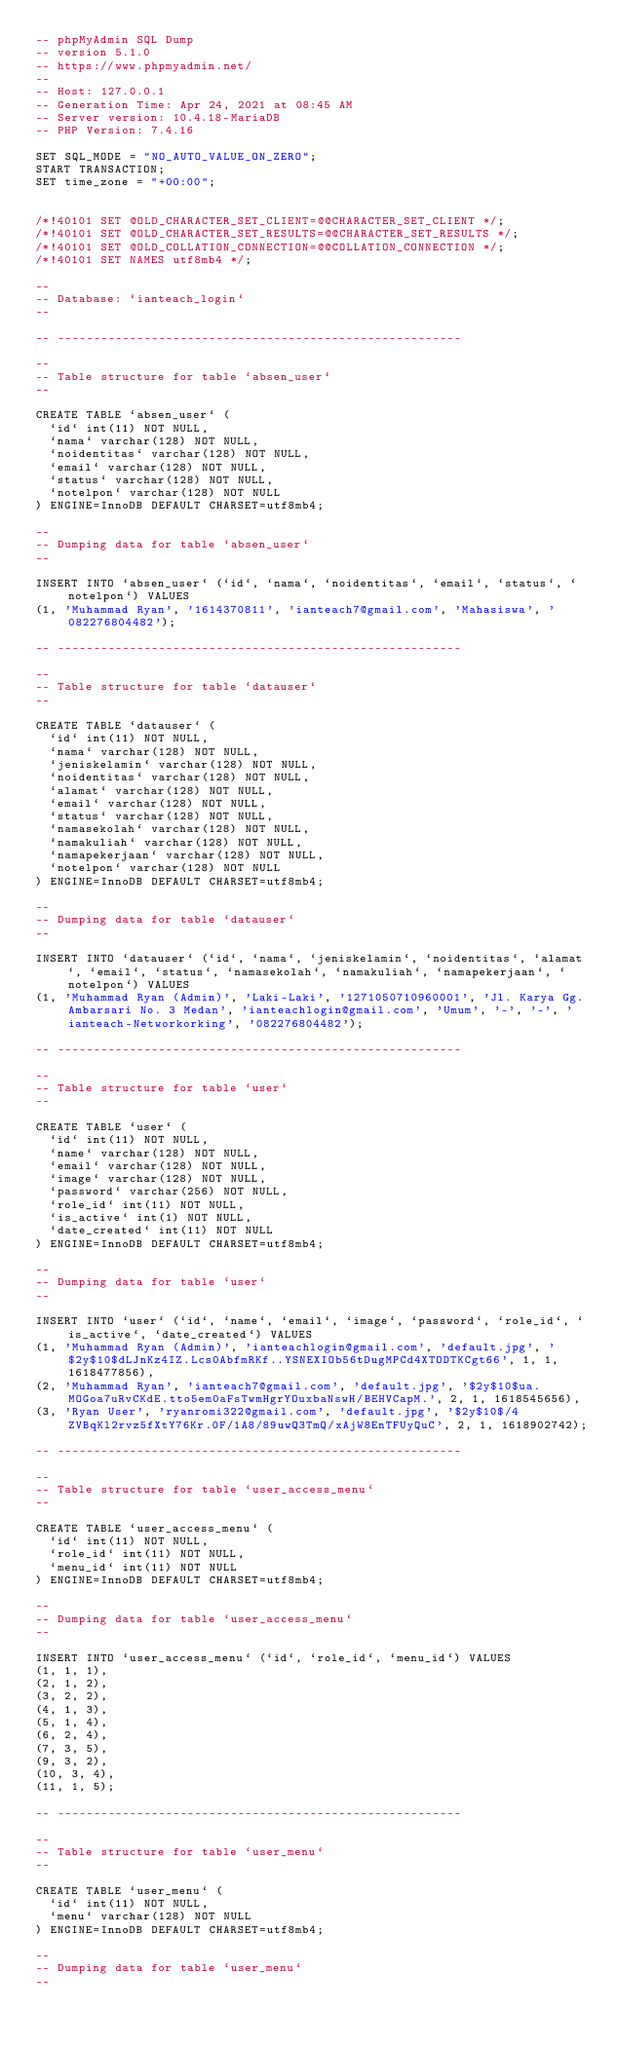Convert code to text. <code><loc_0><loc_0><loc_500><loc_500><_SQL_>-- phpMyAdmin SQL Dump
-- version 5.1.0
-- https://www.phpmyadmin.net/
--
-- Host: 127.0.0.1
-- Generation Time: Apr 24, 2021 at 08:45 AM
-- Server version: 10.4.18-MariaDB
-- PHP Version: 7.4.16

SET SQL_MODE = "NO_AUTO_VALUE_ON_ZERO";
START TRANSACTION;
SET time_zone = "+00:00";


/*!40101 SET @OLD_CHARACTER_SET_CLIENT=@@CHARACTER_SET_CLIENT */;
/*!40101 SET @OLD_CHARACTER_SET_RESULTS=@@CHARACTER_SET_RESULTS */;
/*!40101 SET @OLD_COLLATION_CONNECTION=@@COLLATION_CONNECTION */;
/*!40101 SET NAMES utf8mb4 */;

--
-- Database: `ianteach_login`
--

-- --------------------------------------------------------

--
-- Table structure for table `absen_user`
--

CREATE TABLE `absen_user` (
  `id` int(11) NOT NULL,
  `nama` varchar(128) NOT NULL,
  `noidentitas` varchar(128) NOT NULL,
  `email` varchar(128) NOT NULL,
  `status` varchar(128) NOT NULL,
  `notelpon` varchar(128) NOT NULL
) ENGINE=InnoDB DEFAULT CHARSET=utf8mb4;

--
-- Dumping data for table `absen_user`
--

INSERT INTO `absen_user` (`id`, `nama`, `noidentitas`, `email`, `status`, `notelpon`) VALUES
(1, 'Muhammad Ryan', '1614370811', 'ianteach7@gmail.com', 'Mahasiswa', '082276804482');

-- --------------------------------------------------------

--
-- Table structure for table `datauser`
--

CREATE TABLE `datauser` (
  `id` int(11) NOT NULL,
  `nama` varchar(128) NOT NULL,
  `jeniskelamin` varchar(128) NOT NULL,
  `noidentitas` varchar(128) NOT NULL,
  `alamat` varchar(128) NOT NULL,
  `email` varchar(128) NOT NULL,
  `status` varchar(128) NOT NULL,
  `namasekolah` varchar(128) NOT NULL,
  `namakuliah` varchar(128) NOT NULL,
  `namapekerjaan` varchar(128) NOT NULL,
  `notelpon` varchar(128) NOT NULL
) ENGINE=InnoDB DEFAULT CHARSET=utf8mb4;

--
-- Dumping data for table `datauser`
--

INSERT INTO `datauser` (`id`, `nama`, `jeniskelamin`, `noidentitas`, `alamat`, `email`, `status`, `namasekolah`, `namakuliah`, `namapekerjaan`, `notelpon`) VALUES
(1, 'Muhammad Ryan (Admin)', 'Laki-Laki', '1271050710960001', 'Jl. Karya Gg. Ambarsari No. 3 Medan', 'ianteachlogin@gmail.com', 'Umum', '-', '-', 'ianteach-Networkorking', '082276804482');

-- --------------------------------------------------------

--
-- Table structure for table `user`
--

CREATE TABLE `user` (
  `id` int(11) NOT NULL,
  `name` varchar(128) NOT NULL,
  `email` varchar(128) NOT NULL,
  `image` varchar(128) NOT NULL,
  `password` varchar(256) NOT NULL,
  `role_id` int(11) NOT NULL,
  `is_active` int(1) NOT NULL,
  `date_created` int(11) NOT NULL
) ENGINE=InnoDB DEFAULT CHARSET=utf8mb4;

--
-- Dumping data for table `user`
--

INSERT INTO `user` (`id`, `name`, `email`, `image`, `password`, `role_id`, `is_active`, `date_created`) VALUES
(1, 'Muhammad Ryan (Admin)', 'ianteachlogin@gmail.com', 'default.jpg', '$2y$10$dLJnKz4IZ.Lcs0AbfmRKf..YSNEXIOb56tDugMPCd4XTODTKCgt66', 1, 1, 1618477856),
(2, 'Muhammad Ryan', 'ianteach7@gmail.com', 'default.jpg', '$2y$10$ua.MOGoa7uRvCKdE.tto5em0aFsTwmHgrYOuxbaNswH/BEHVCapM.', 2, 1, 1618545656),
(3, 'Ryan User', 'ryanromi322@gmail.com', 'default.jpg', '$2y$10$/4ZVBqKl2rvz5fXtY76Kr.0F/1A8/89uwQ3TmQ/xAjW8EnTFUyQuC', 2, 1, 1618902742);

-- --------------------------------------------------------

--
-- Table structure for table `user_access_menu`
--

CREATE TABLE `user_access_menu` (
  `id` int(11) NOT NULL,
  `role_id` int(11) NOT NULL,
  `menu_id` int(11) NOT NULL
) ENGINE=InnoDB DEFAULT CHARSET=utf8mb4;

--
-- Dumping data for table `user_access_menu`
--

INSERT INTO `user_access_menu` (`id`, `role_id`, `menu_id`) VALUES
(1, 1, 1),
(2, 1, 2),
(3, 2, 2),
(4, 1, 3),
(5, 1, 4),
(6, 2, 4),
(7, 3, 5),
(9, 3, 2),
(10, 3, 4),
(11, 1, 5);

-- --------------------------------------------------------

--
-- Table structure for table `user_menu`
--

CREATE TABLE `user_menu` (
  `id` int(11) NOT NULL,
  `menu` varchar(128) NOT NULL
) ENGINE=InnoDB DEFAULT CHARSET=utf8mb4;

--
-- Dumping data for table `user_menu`
--
</code> 